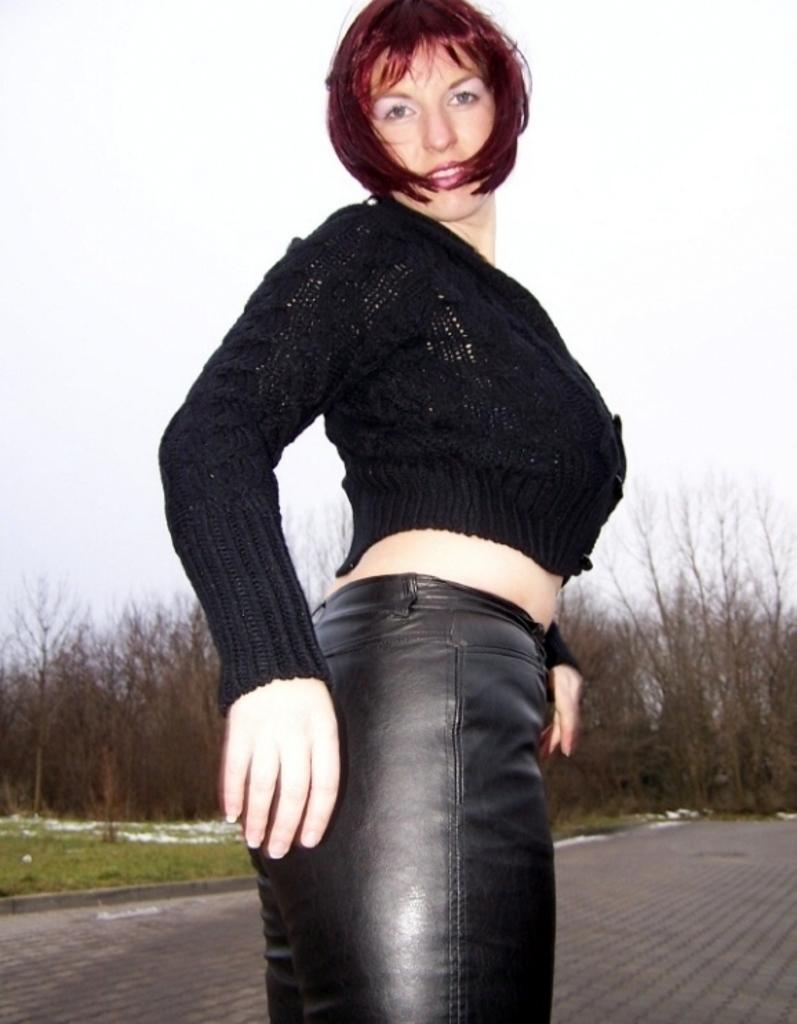Who is the main subject in the image? There is a woman in the image. What is the woman doing in the image? The woman is standing on the floor. What is the woman wearing in the image? The woman is wearing a black top and black pants. What can be seen in the background of the image? There are trees in the background of the image. What is visible at the top of the image? The sky is visible at the top of the image. What idea does the woman have about the memory of the way she used to dress? The image does not provide any information about the woman's ideas, memories, or past fashion choices. 